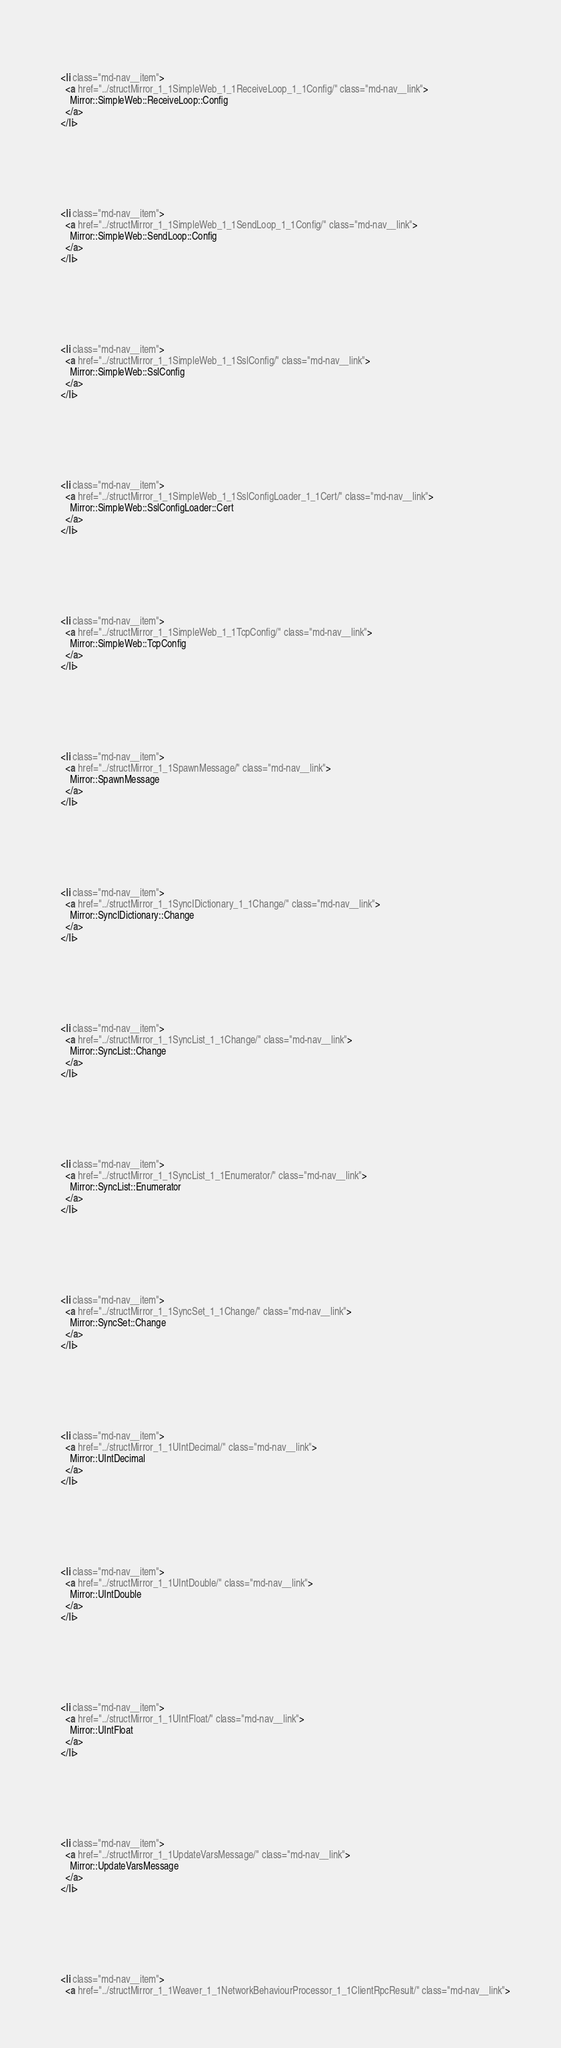<code> <loc_0><loc_0><loc_500><loc_500><_HTML_>  
  
    <li class="md-nav__item">
      <a href="../structMirror_1_1SimpleWeb_1_1ReceiveLoop_1_1Config/" class="md-nav__link">
        Mirror::SimpleWeb::ReceiveLoop::Config
      </a>
    </li>
  

          
            
  
  
  
    <li class="md-nav__item">
      <a href="../structMirror_1_1SimpleWeb_1_1SendLoop_1_1Config/" class="md-nav__link">
        Mirror::SimpleWeb::SendLoop::Config
      </a>
    </li>
  

          
            
  
  
  
    <li class="md-nav__item">
      <a href="../structMirror_1_1SimpleWeb_1_1SslConfig/" class="md-nav__link">
        Mirror::SimpleWeb::SslConfig
      </a>
    </li>
  

          
            
  
  
  
    <li class="md-nav__item">
      <a href="../structMirror_1_1SimpleWeb_1_1SslConfigLoader_1_1Cert/" class="md-nav__link">
        Mirror::SimpleWeb::SslConfigLoader::Cert
      </a>
    </li>
  

          
            
  
  
  
    <li class="md-nav__item">
      <a href="../structMirror_1_1SimpleWeb_1_1TcpConfig/" class="md-nav__link">
        Mirror::SimpleWeb::TcpConfig
      </a>
    </li>
  

          
            
  
  
  
    <li class="md-nav__item">
      <a href="../structMirror_1_1SpawnMessage/" class="md-nav__link">
        Mirror::SpawnMessage
      </a>
    </li>
  

          
            
  
  
  
    <li class="md-nav__item">
      <a href="../structMirror_1_1SyncIDictionary_1_1Change/" class="md-nav__link">
        Mirror::SyncIDictionary::Change
      </a>
    </li>
  

          
            
  
  
  
    <li class="md-nav__item">
      <a href="../structMirror_1_1SyncList_1_1Change/" class="md-nav__link">
        Mirror::SyncList::Change
      </a>
    </li>
  

          
            
  
  
  
    <li class="md-nav__item">
      <a href="../structMirror_1_1SyncList_1_1Enumerator/" class="md-nav__link">
        Mirror::SyncList::Enumerator
      </a>
    </li>
  

          
            
  
  
  
    <li class="md-nav__item">
      <a href="../structMirror_1_1SyncSet_1_1Change/" class="md-nav__link">
        Mirror::SyncSet::Change
      </a>
    </li>
  

          
            
  
  
  
    <li class="md-nav__item">
      <a href="../structMirror_1_1UIntDecimal/" class="md-nav__link">
        Mirror::UIntDecimal
      </a>
    </li>
  

          
            
  
  
  
    <li class="md-nav__item">
      <a href="../structMirror_1_1UIntDouble/" class="md-nav__link">
        Mirror::UIntDouble
      </a>
    </li>
  

          
            
  
  
  
    <li class="md-nav__item">
      <a href="../structMirror_1_1UIntFloat/" class="md-nav__link">
        Mirror::UIntFloat
      </a>
    </li>
  

          
            
  
  
  
    <li class="md-nav__item">
      <a href="../structMirror_1_1UpdateVarsMessage/" class="md-nav__link">
        Mirror::UpdateVarsMessage
      </a>
    </li>
  

          
            
  
  
  
    <li class="md-nav__item">
      <a href="../structMirror_1_1Weaver_1_1NetworkBehaviourProcessor_1_1ClientRpcResult/" class="md-nav__link"></code> 